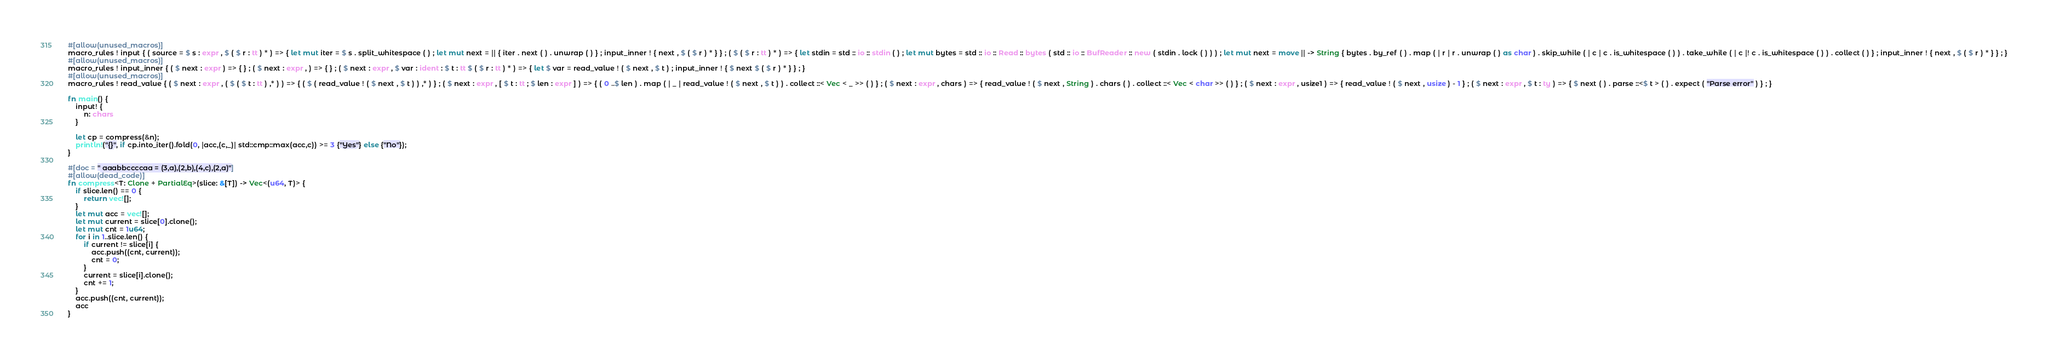Convert code to text. <code><loc_0><loc_0><loc_500><loc_500><_Rust_>#[allow(unused_macros)]
macro_rules ! input { ( source = $ s : expr , $ ( $ r : tt ) * ) => { let mut iter = $ s . split_whitespace ( ) ; let mut next = || { iter . next ( ) . unwrap ( ) } ; input_inner ! { next , $ ( $ r ) * } } ; ( $ ( $ r : tt ) * ) => { let stdin = std :: io :: stdin ( ) ; let mut bytes = std :: io :: Read :: bytes ( std :: io :: BufReader :: new ( stdin . lock ( ) ) ) ; let mut next = move || -> String { bytes . by_ref ( ) . map ( | r | r . unwrap ( ) as char ) . skip_while ( | c | c . is_whitespace ( ) ) . take_while ( | c |! c . is_whitespace ( ) ) . collect ( ) } ; input_inner ! { next , $ ( $ r ) * } } ; }
#[allow(unused_macros)]
macro_rules ! input_inner { ( $ next : expr ) => { } ; ( $ next : expr , ) => { } ; ( $ next : expr , $ var : ident : $ t : tt $ ( $ r : tt ) * ) => { let $ var = read_value ! ( $ next , $ t ) ; input_inner ! { $ next $ ( $ r ) * } } ; }
#[allow(unused_macros)]
macro_rules ! read_value { ( $ next : expr , ( $ ( $ t : tt ) ,* ) ) => { ( $ ( read_value ! ( $ next , $ t ) ) ,* ) } ; ( $ next : expr , [ $ t : tt ; $ len : expr ] ) => { ( 0 ..$ len ) . map ( | _ | read_value ! ( $ next , $ t ) ) . collect ::< Vec < _ >> ( ) } ; ( $ next : expr , chars ) => { read_value ! ( $ next , String ) . chars ( ) . collect ::< Vec < char >> ( ) } ; ( $ next : expr , usize1 ) => { read_value ! ( $ next , usize ) - 1 } ; ( $ next : expr , $ t : ty ) => { $ next ( ) . parse ::<$ t > ( ) . expect ( "Parse error" ) } ; }

fn main() {
    input! {
        n: chars
    }

    let cp = compress(&n);
    println!("{}", if cp.into_iter().fold(0, |acc,(c,_)| std::cmp::max(acc,c)) >= 3 {"Yes"} else {"No"});
}

#[doc = " aaabbccccaa = (3,a),(2,b),(4,c),(2,a)"]
#[allow(dead_code)]
fn compress<T: Clone + PartialEq>(slice: &[T]) -> Vec<(u64, T)> {
    if slice.len() == 0 {
        return vec![];
    }
    let mut acc = vec![];
    let mut current = slice[0].clone();
    let mut cnt = 1u64;
    for i in 1..slice.len() {
        if current != slice[i] {
            acc.push((cnt, current));
            cnt = 0;
        }
        current = slice[i].clone();
        cnt += 1;
    }
    acc.push((cnt, current));
    acc
}</code> 